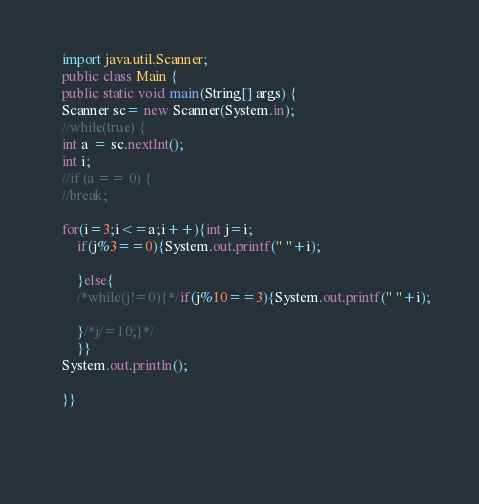<code> <loc_0><loc_0><loc_500><loc_500><_Java_>	import java.util.Scanner;
	public class Main {
	public static void main(String[] args) {
	Scanner sc= new Scanner(System.in);
	//while(true) {
	int a = sc.nextInt();
	int i;
	//if (a == 0) {
	//break;
	
	for(i=3;i<=a;i++){int j=i;
		if(j%3==0){System.out.printf(" "+i);
		
		}else{
		/*while(j!=0){*/if(j%10==3){System.out.printf(" "+i);
	     
		}/*j/=10;}*/
		}}
	System.out.println();
	
	}}
	
	
	</code> 